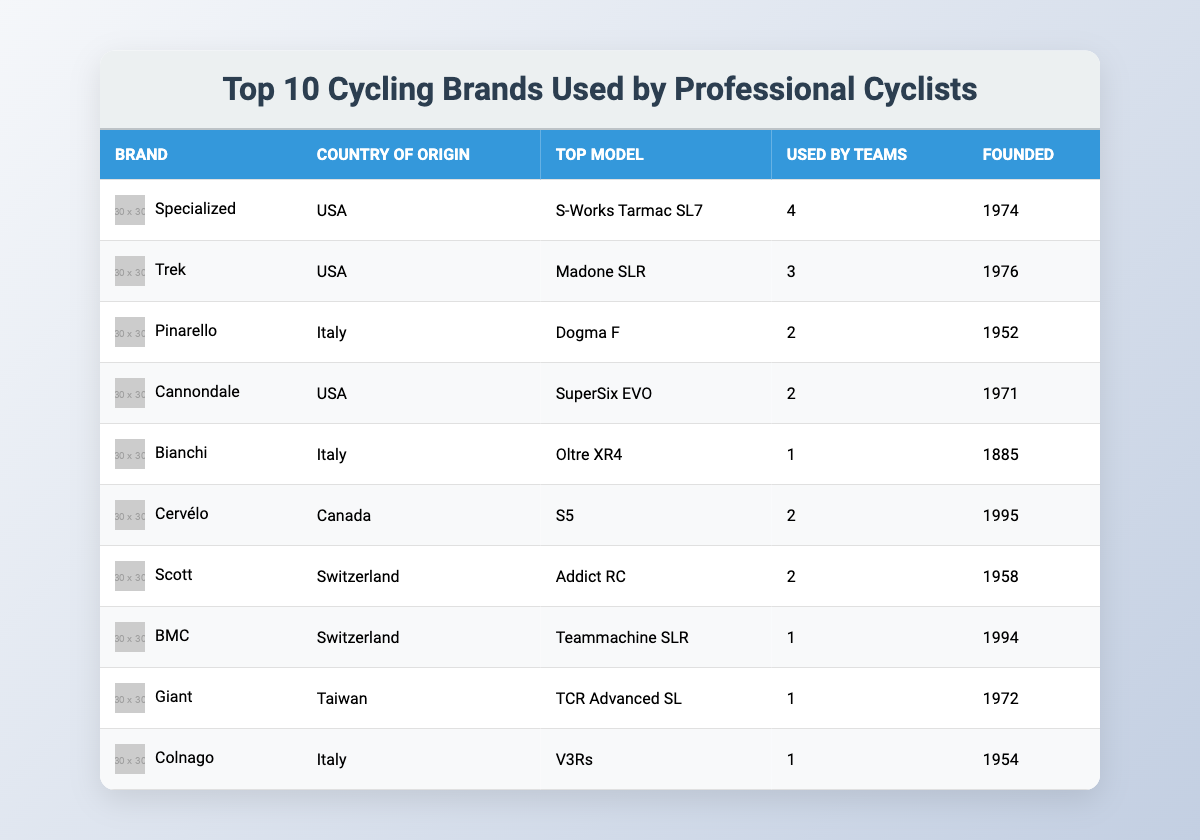What is the top model of Specialized? The table lists the top model for each brand. For Specialized, we look under the "Top Model" column next to it, which shows "S-Works Tarmac SL7."
Answer: S-Works Tarmac SL7 How many teams are using Trek bikes? In the "Used by Teams" column for Trek, it shows the number 3, indicating that three teams are using Trek bikes.
Answer: 3 Which brand has the oldest founding year? By checking the "Founded" column, we can see that Bianchi was founded in 1885, which is the oldest year listed.
Answer: Bianchi Is Cannondale used by more teams than Pinarello? Cannondale has 2 teams using it while Pinarello also has 2 teams using it. Since both values are the same, the answer is no, Cannondale is not used by more teams than Pinarello.
Answer: No What is the average number of teams using these top brands? To find the average, we need to sum the values in the "Used by Teams" column: (4 + 3 + 2 + 2 + 1 + 2 + 2 + 1 + 1 + 1) = 20. There are 10 brands, so the average is 20 / 10 = 2.
Answer: 2 Which brand is from Canada? Looking at the "Country of Origin" column, Cervélo is the only brand listed as being from Canada.
Answer: Cervélo How many brands have been used by exactly 1 team? In the "Used by Teams" column, we can see that Bianchi, BMC, Giant, and Colnago each have "1" listed. That makes a total of 4 brands.
Answer: 4 Which country has the most brands represented in this table? By counting the "Country of Origin" entries, we see USA has 4 brands (Specialized, Trek, Cannondale, and Giant). Other countries have fewer. Therefore, the USA has the most represented.
Answer: USA Is there any brand founded after 1990? We check the "Founded" column for any brands that have years greater than 1990. Cervélo (1995) is the only brand that fits this criterion.
Answer: Yes Which brand has the highest number of teams using it? We can look at the "Used by Teams" column to find the highest number. Specialized has 4, which is the maximum for any brand listed.
Answer: Specialized 